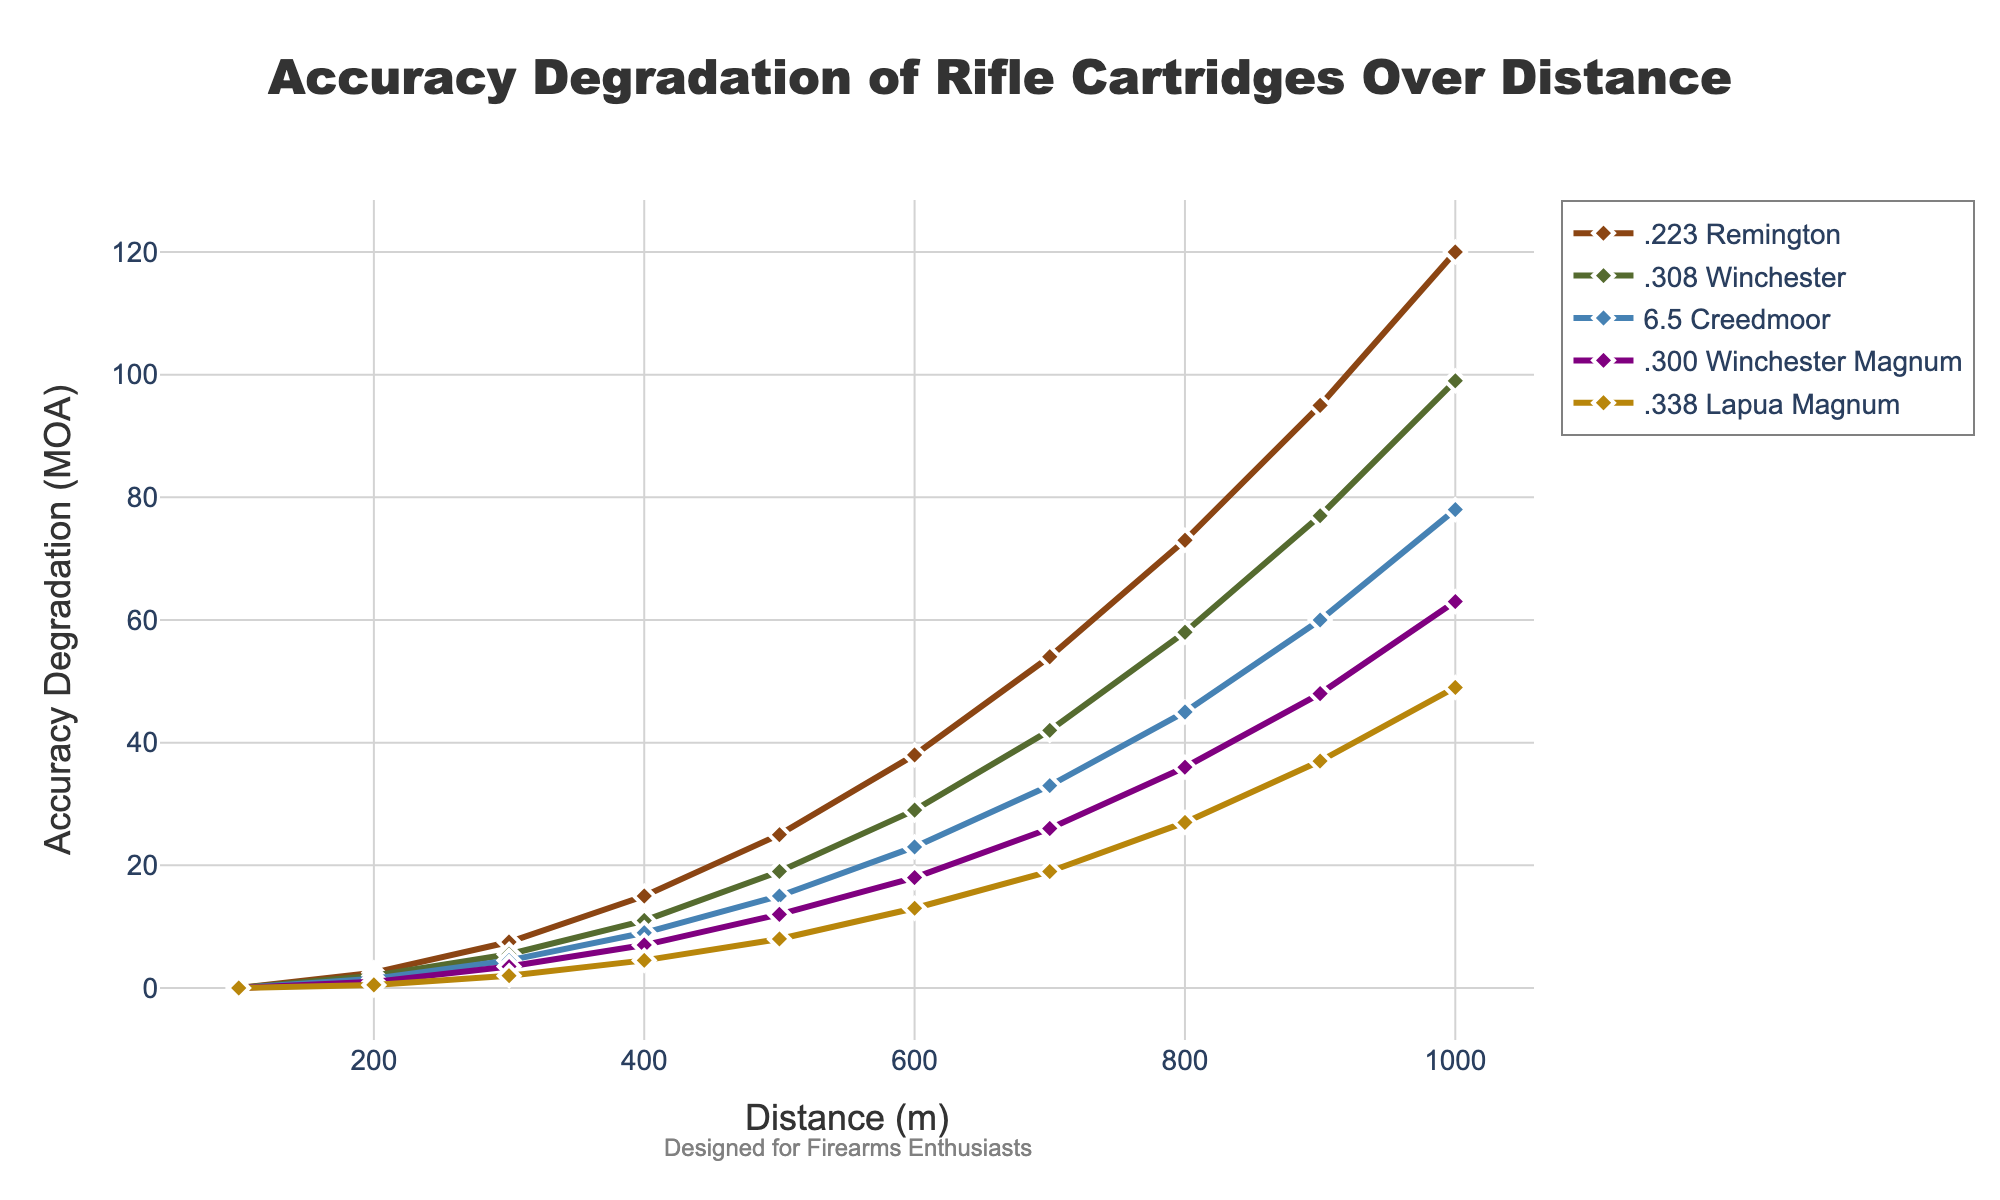What cartridge has the highest accuracy degradation at 1000m? At 1000m, compare the highest y-axis values for each cartridge. The highest value is 120 for .223 Remington.
Answer: .223 Remington Which cartridge shows the least degradation at 500m? At 500m, compare the y-axis values for each cartridge. The lowest value is 8 for .338 Lapua Magnum.
Answer: .338 Lapua Magnum Between 400m and 500m, how much does the accuracy degradation increase for .308 Winchester? Look at the values for .308 Winchester at 400m and 500m, which are 11 and 19 respectively. Subtract 11 from 19 to find the increase.
Answer: 8 What is the total accuracy degradation for 6.5 Creedmoor from 100m to 600m? Sum the y-axis values for 6.5 Creedmoor from 100m to 600m: 0 + 1.5 + 4.5 + 9 + 15 + 23.
Answer: 53 By how much is the degradation at 800m greater for .300 Winchester Magnum compared to .223 Remington? Subtract the y-axis value of .223 Remington at 800m (73) from the y-axis value of .300 Winchester Magnum at 800m (36).
Answer: -37 Which cartridge shows the most significant increase in accuracy degradation between 900m and 1000m? Compare the increases in y-axis values between 900m and 1000m for all cartridges. .223 Remington has the largest increase from 95 to 120.
Answer: .223 Remington Is there any point where .338 Lapua Magnum's accuracy degradation is more than double that of .300 Winchester Magnum? Double the y-axis values for .300 Winchester Magnum and compare with those of .338 Lapua Magnum for each distance. No such point exists.
Answer: No How is the accuracy degradation trend for .223 Remington visually represented on the plot? The trend line for .223 Remington starts at 0 MOA at 100m and steadily increases, reaching its peak at 120 MOA by 1000m. It uses brown-colored diamonds for markers.
Answer: Steadily increasing line with brown diamonds What is the average accuracy degradation for .308 Winchester between 200m and 700m? Sum the y-axis values for .308 Winchester between 200m and 700m: 2 + 5.5 + 11 + 19 + 29 + 42. Divide by 6.
Answer: 18.25 Which cartridge has the least variability in accuracy degradation over the distances shown? Assess the spread of accuracy degradation values for each cartridge. .338 Lapua Magnum has the smallest differences in values.
Answer: .338 Lapua Magnum 